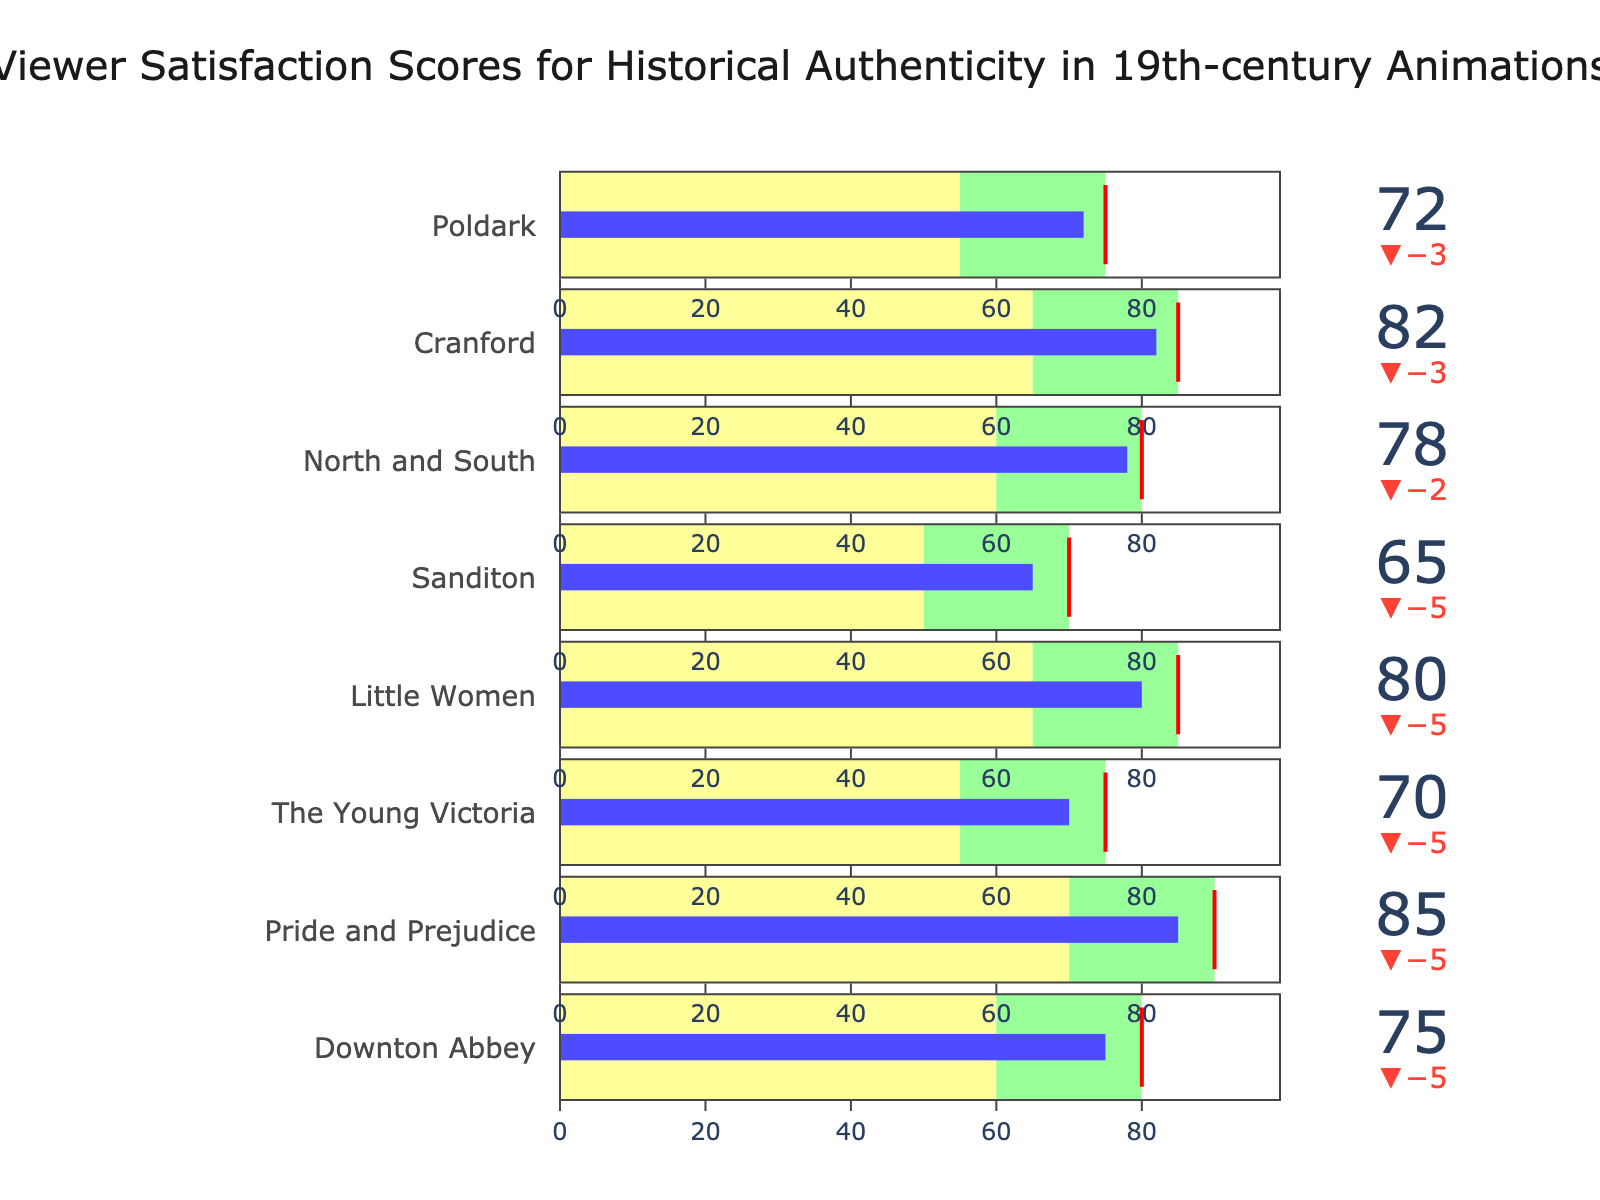What's the title of the figure? The title of the figure is usually found centrally at the top of the chart in larger text. In this case, the title specified in the code is "Viewer Satisfaction Scores for Historical Authenticity in 19th-century Animations".
Answer: Viewer Satisfaction Scores for Historical Authenticity in 19th-century Animations What is the actual satisfaction score for "Poldark"? To find the actual satisfaction score for "Poldark", look for the corresponding section of the bullet chart and read the value labeled as actual. According to the data provided, the actual value for "Poldark" is 72.
Answer: 72 Which animation has the highest satisfaction score? Looking through all the actual satisfaction scores in the chart, "Pride and Prejudice" stands out with the highest actual value of 85.
Answer: Pride and Prejudice What is the target satisfaction score for "The Young Victoria"? By locating "The Young Victoria" in the bullet chart and reading the target value, you can see that the target score is 75.
Answer: 75 What is the difference between "Actual" and "Target" for "Downton Abbey"? The actual value for "Downton Abbey" is 75, while the target value is 80. The difference is 80 - 75 = 5.
Answer: 5 Which categories are within 10 points below their target values? To find the categories within 10 points below their target values, look for those where the difference between the target and actual scores is less than or equal to 10. "Downton Abbey", "Pride and Prejudice", "The Young Victoria", "Little Women", "North and South", "Cranford", and "Poldark" all fit this criterion based on their respective actual and target scores.
Answer: Downton Abbey, Pride and Prejudice, The Young Victoria, Little Women, North and South, Cranford, Poldark Which show has the least difference between actual and target ratings? To find the show with the least difference, compare the differences between actual and target values for each show. "Downton Abbey", "North and South" both have a difference of 2, the smallest value among all.
Answer: Downton Abbey, North and South If "Poor" corresponds to scores below 60 for all shows, which shows fall into the "Average" rating range? Shows within the "Average" rating range have scores between their "Poor" and "Good" thresholds. The "Poor" rating starts from 0 to the "Poor" value of each show and the "Good" value range is from "Average" to "Good". All shows listed fall into the "Average" range because their actual values lie between "Poor" and "Good".
Answer: All shows What is the average satisfaction score across all animations? To calculate the average satisfaction score, sum all actual satisfaction scores and divide by the number of categories: (75 + 85 + 70 + 80 + 65 + 78 + 82 + 72) / 8 = 607 / 8 = 75.875.
Answer: 75.875 Which show has the biggest discrepancy from its target? By comparing the absolute differences between actual and target scores, "Sanditon" has the largest discrepancy with a difference of 5 (70 - 65 = 5).
Answer: Sanditon 